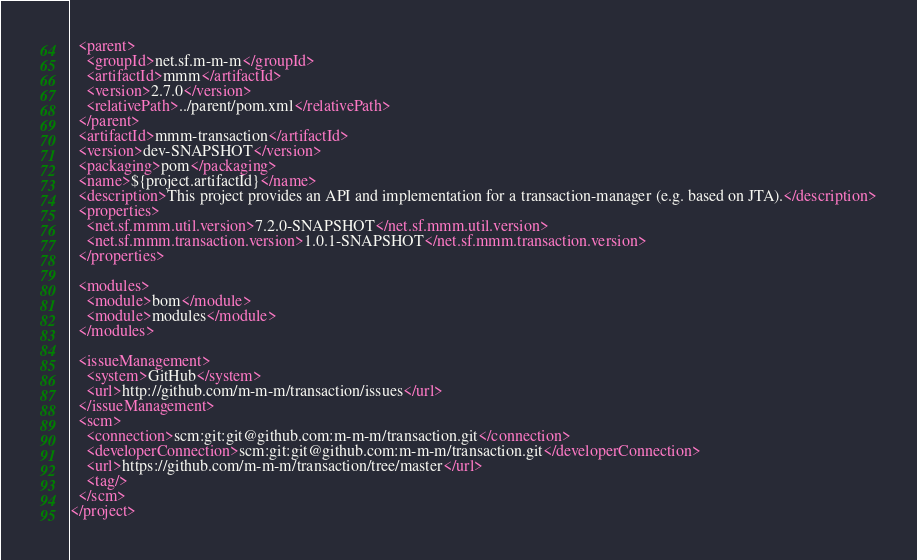<code> <loc_0><loc_0><loc_500><loc_500><_XML_>  <parent>
    <groupId>net.sf.m-m-m</groupId>
    <artifactId>mmm</artifactId>
    <version>2.7.0</version>
    <relativePath>../parent/pom.xml</relativePath>
  </parent>
  <artifactId>mmm-transaction</artifactId>
  <version>dev-SNAPSHOT</version>
  <packaging>pom</packaging>
  <name>${project.artifactId}</name>
  <description>This project provides an API and implementation for a transaction-manager (e.g. based on JTA).</description>
  <properties>
    <net.sf.mmm.util.version>7.2.0-SNAPSHOT</net.sf.mmm.util.version>
    <net.sf.mmm.transaction.version>1.0.1-SNAPSHOT</net.sf.mmm.transaction.version>
  </properties>

  <modules>
    <module>bom</module>
    <module>modules</module>
  </modules>

  <issueManagement>
    <system>GitHub</system>
    <url>http://github.com/m-m-m/transaction/issues</url>
  </issueManagement>
  <scm>
    <connection>scm:git:git@github.com:m-m-m/transaction.git</connection>
    <developerConnection>scm:git:git@github.com:m-m-m/transaction.git</developerConnection>
    <url>https://github.com/m-m-m/transaction/tree/master</url>
    <tag/>
  </scm>
</project>
</code> 